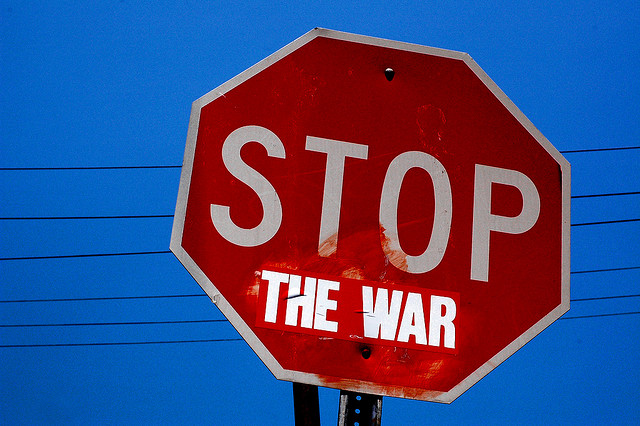Identify the text contained in this image. WAR STOP THE 